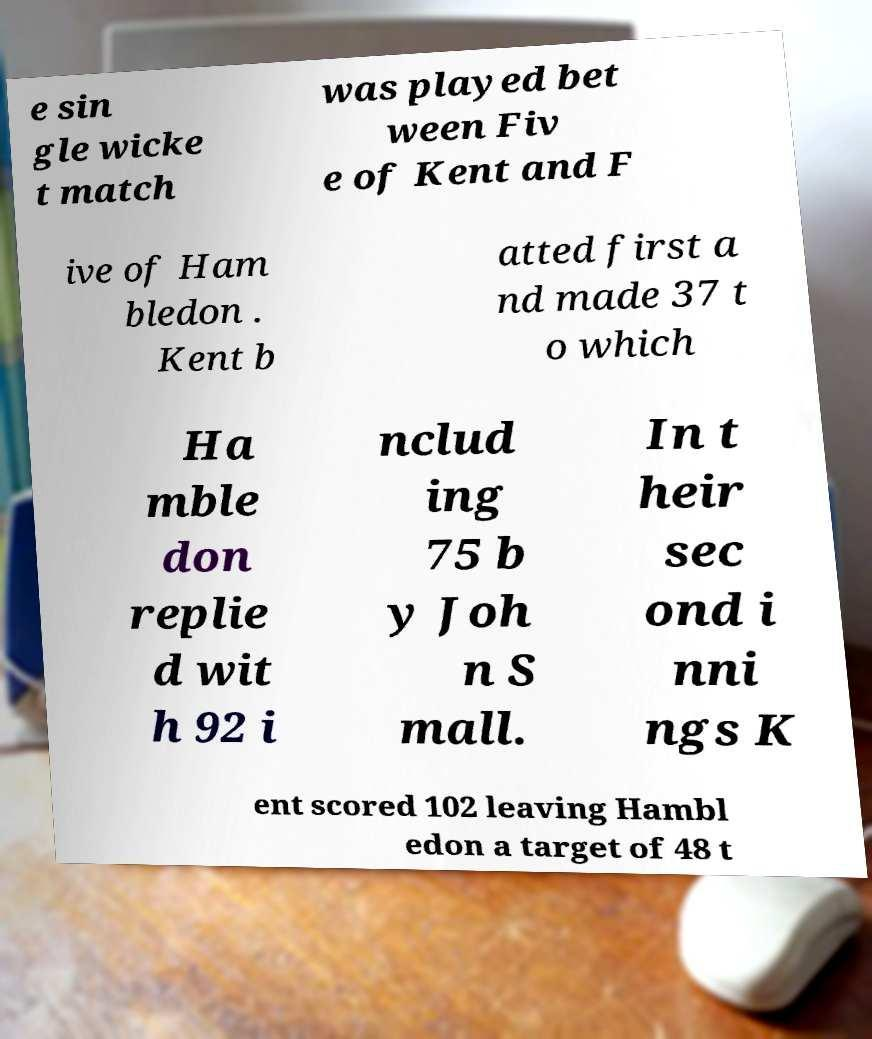Could you extract and type out the text from this image? e sin gle wicke t match was played bet ween Fiv e of Kent and F ive of Ham bledon . Kent b atted first a nd made 37 t o which Ha mble don replie d wit h 92 i nclud ing 75 b y Joh n S mall. In t heir sec ond i nni ngs K ent scored 102 leaving Hambl edon a target of 48 t 